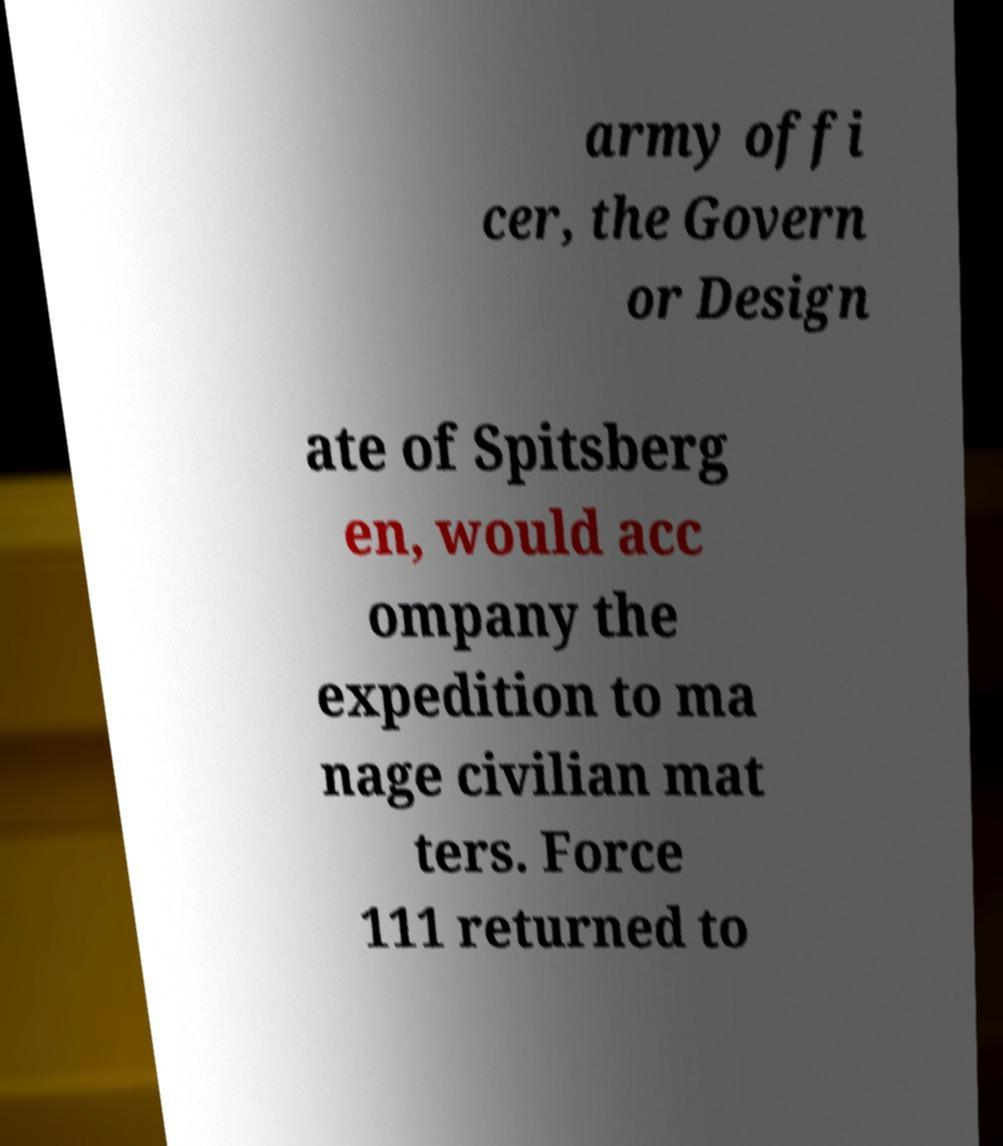There's text embedded in this image that I need extracted. Can you transcribe it verbatim? army offi cer, the Govern or Design ate of Spitsberg en, would acc ompany the expedition to ma nage civilian mat ters. Force 111 returned to 